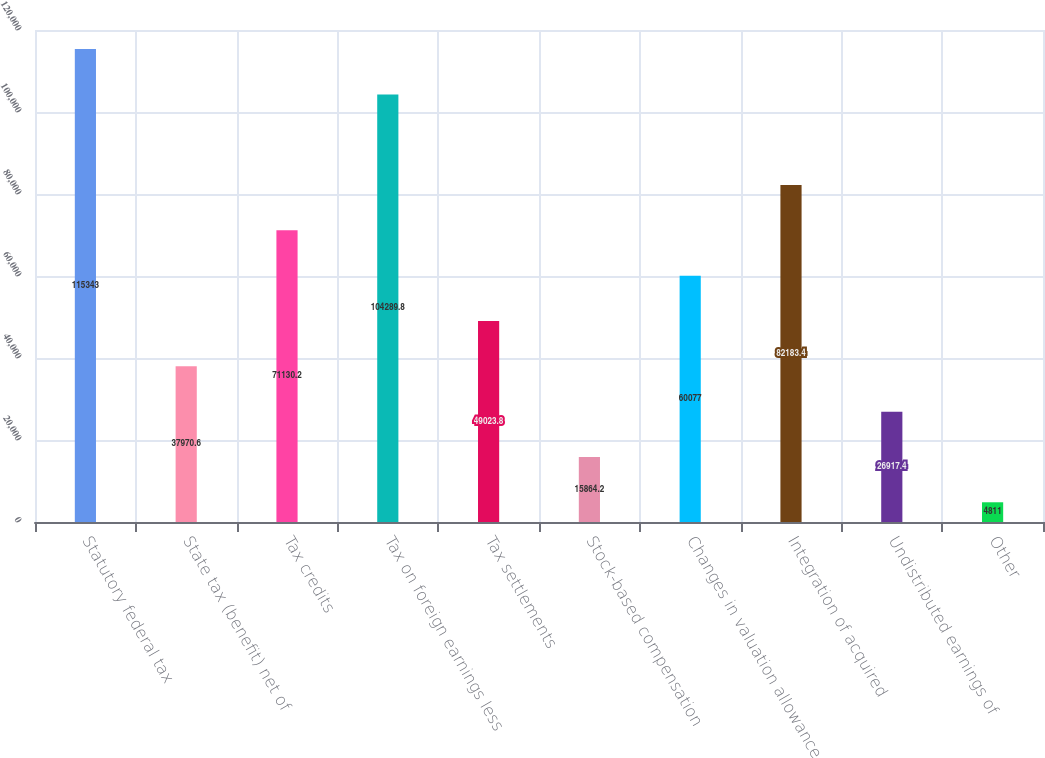Convert chart. <chart><loc_0><loc_0><loc_500><loc_500><bar_chart><fcel>Statutory federal tax<fcel>State tax (benefit) net of<fcel>Tax credits<fcel>Tax on foreign earnings less<fcel>Tax settlements<fcel>Stock-based compensation<fcel>Changes in valuation allowance<fcel>Integration of acquired<fcel>Undistributed earnings of<fcel>Other<nl><fcel>115343<fcel>37970.6<fcel>71130.2<fcel>104290<fcel>49023.8<fcel>15864.2<fcel>60077<fcel>82183.4<fcel>26917.4<fcel>4811<nl></chart> 